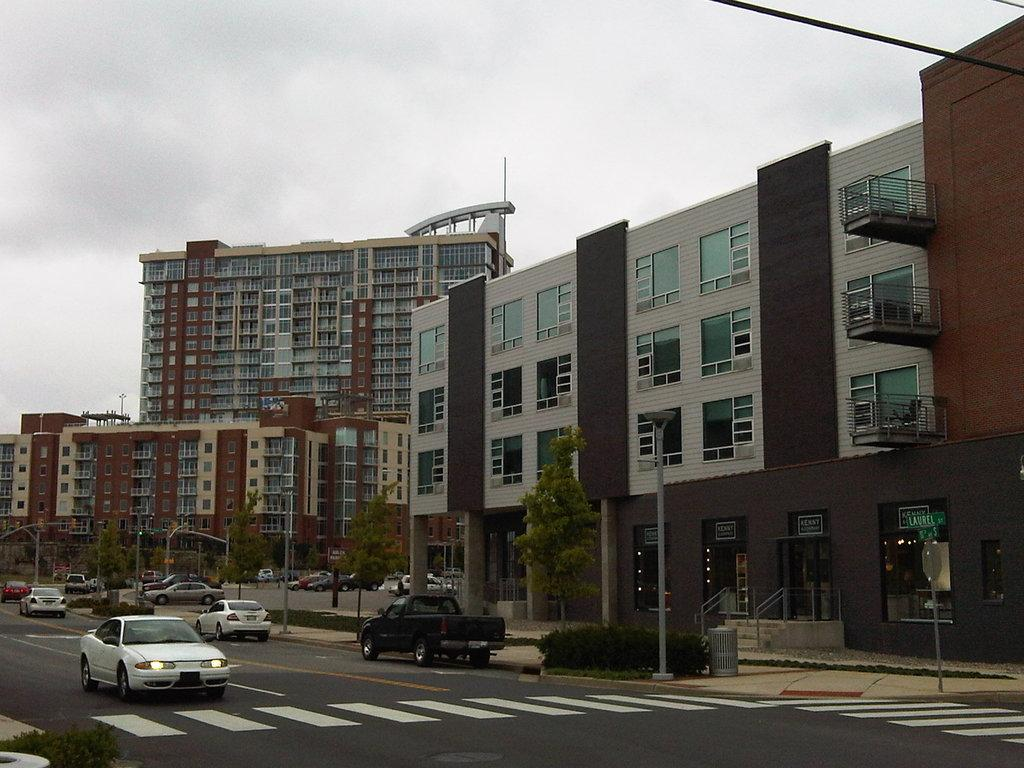What is located in the center of the image? There are buildings, trees, and poles in the center of the image. What can be seen on the road in the image? There are vehicles on the road in the image. What is visible in the sky in the image? The sky is visible at the top of the image. What else can be seen in the image besides the buildings, trees, and vehicles? There are lights and wires visible in the image. What type of book is being read by the flesh in the image? There is no flesh or book present in the image. How many yams are visible on the poles in the image? There are no yams present in the image. 